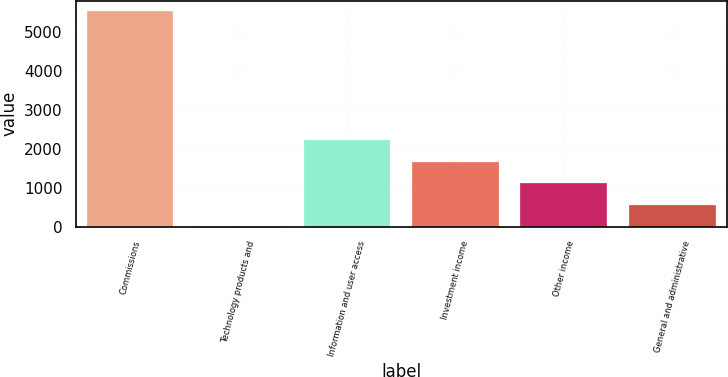Convert chart to OTSL. <chart><loc_0><loc_0><loc_500><loc_500><bar_chart><fcel>Commissions<fcel>Technology products and<fcel>Information and user access<fcel>Investment income<fcel>Other income<fcel>General and administrative<nl><fcel>5541<fcel>16<fcel>2226<fcel>1673.5<fcel>1121<fcel>568.5<nl></chart> 